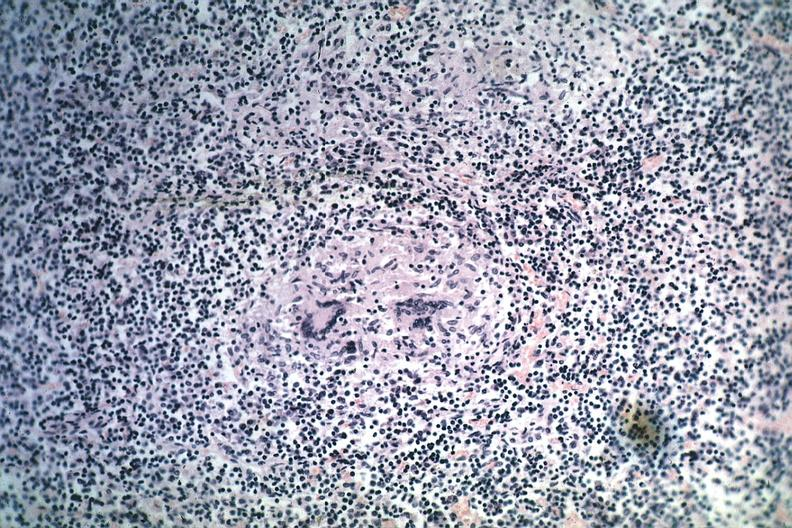what is present?
Answer the question using a single word or phrase. Lymph node 